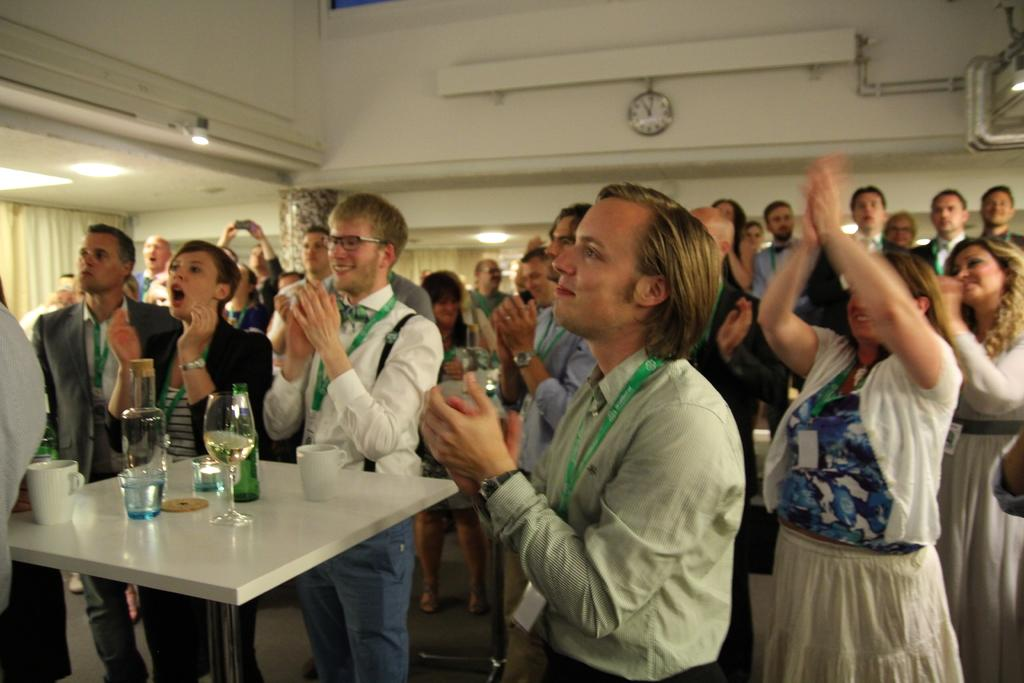What are the people in the image doing? The people in the image are standing in a hall and clapping. What can be seen in the hall besides the people? There is a table in the hall. What items are on the table? Bottles, cups, and glasses are present on the table. What type of wire is being used to hold the lettuce in the image? There is no wire or lettuce present in the image. 